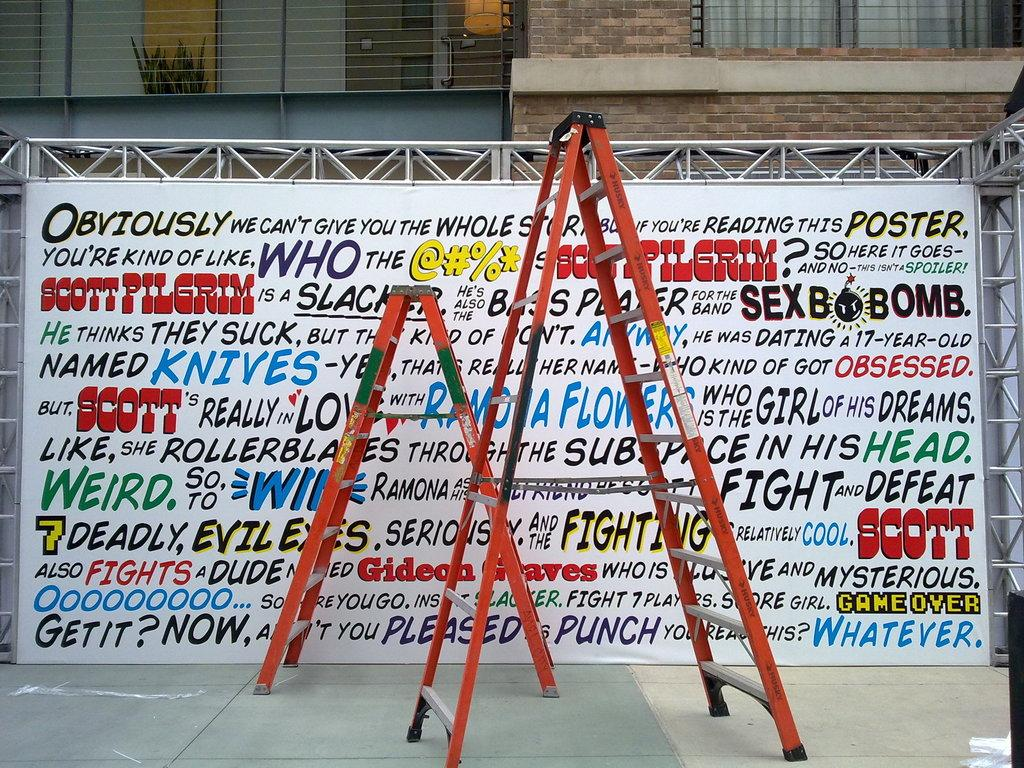<image>
Give a short and clear explanation of the subsequent image. An art display showing many different kinds of texts and fonts about Scott Pilgrim. 